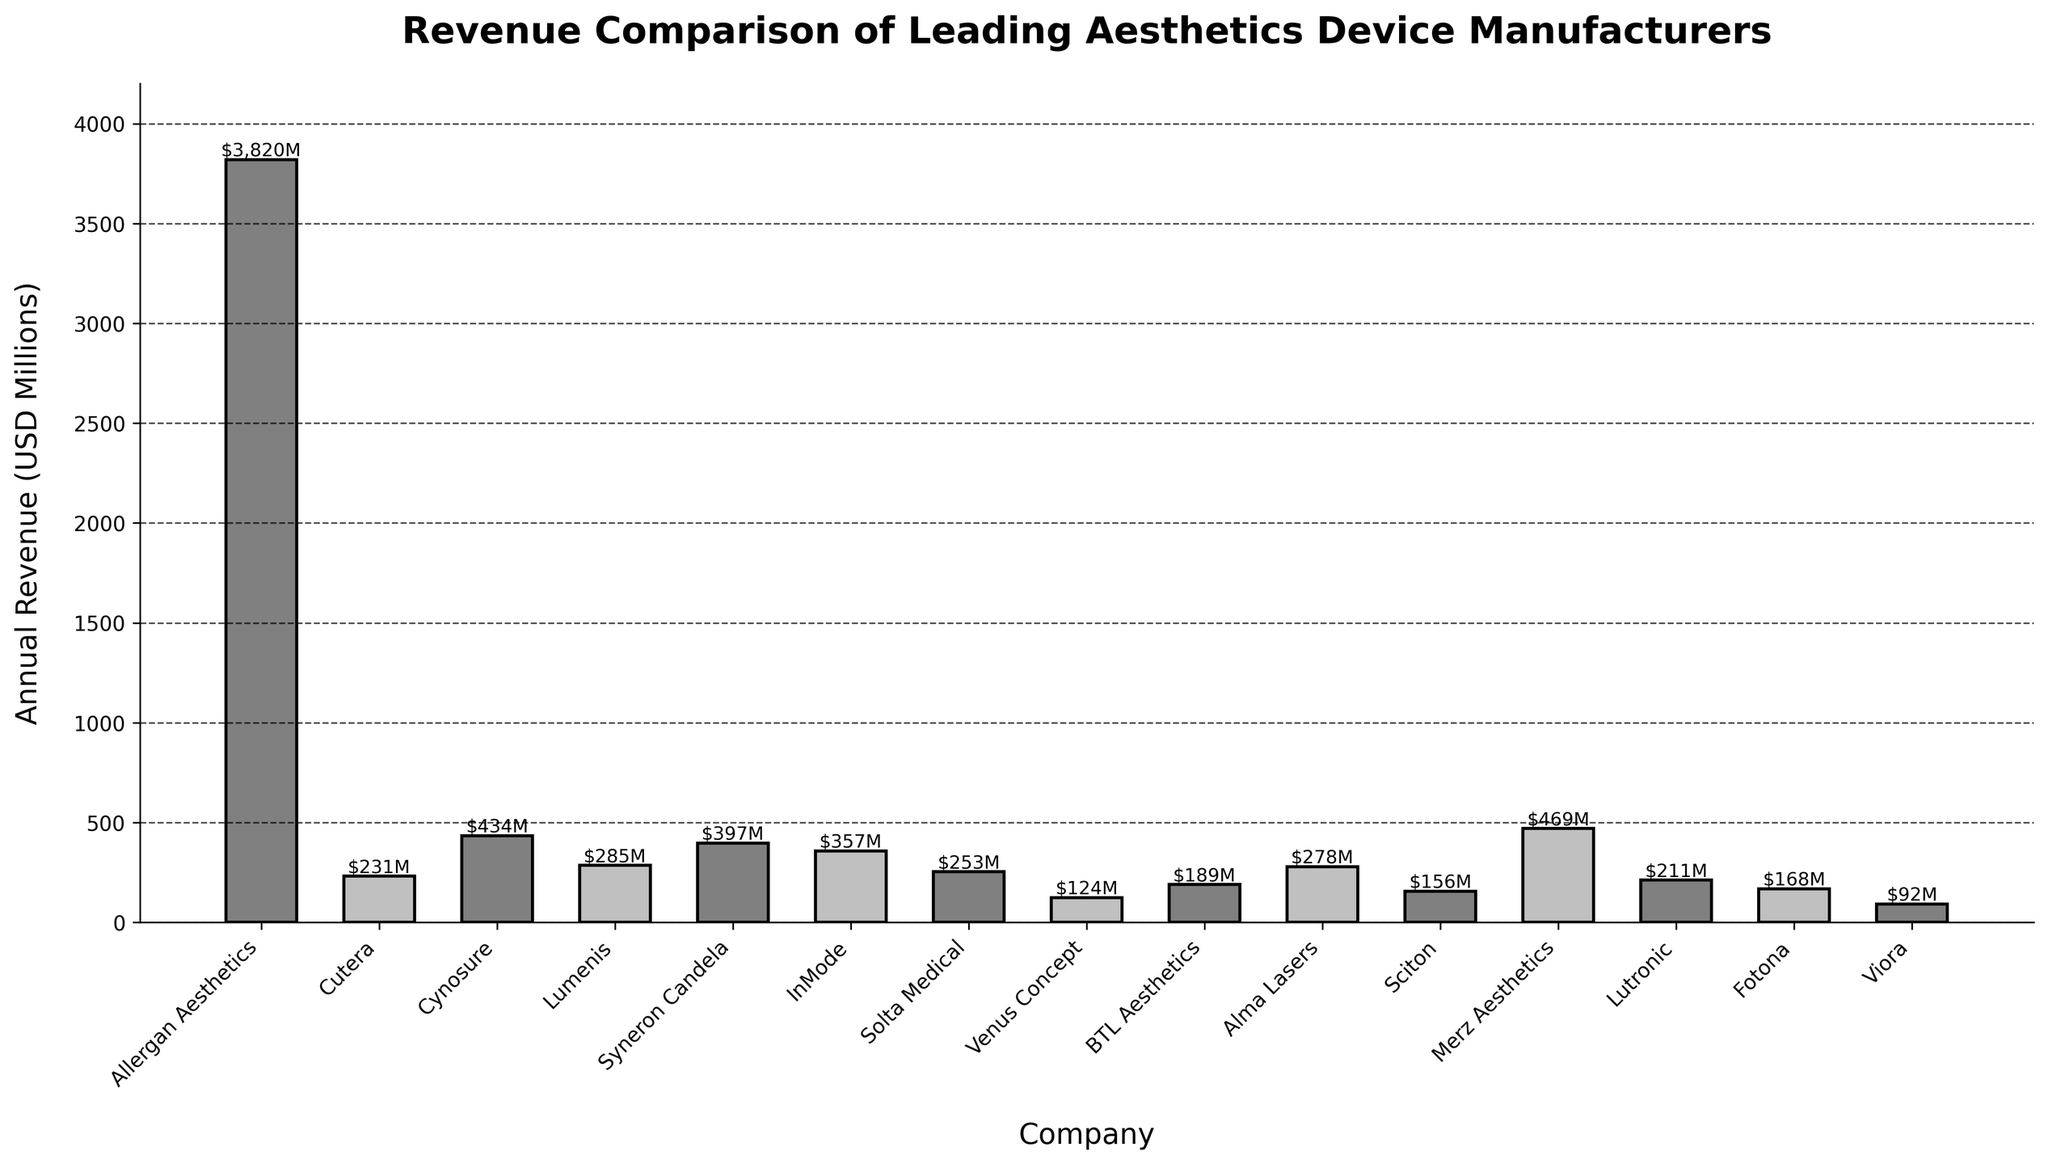Which company has the highest annual revenue? The height of the bars represents the annual revenue for each company, and the tallest bar indicates the company with the highest annual revenue. Allergan Aesthetics has the highest revenue.
Answer: Allergan Aesthetics Which companies have an annual revenue greater than $400 million? Easily identifiable by the heights of the bars, only those whose heights surpass the $400 million mark qualify. Allergan Aesthetics and Merz Aesthetics are the ones.
Answer: Allergan Aesthetics, Merz Aesthetics What is the total revenue of the top three companies? Sum the heights of the bars for the three highest values: Allergan Aesthetics ($3,820M), Merz Aesthetics ($469M), and Cynosure ($434M). The total is $3,820M + $469M + $434M.
Answer: $4,723M Which company has the lowest annual revenue? The shortest bar on the chart indicates the company with the lowest annual revenue. This bar represents Viora.
Answer: Viora What is the revenue range of the companies? Subtract the lowest revenue (Viora's $92M) from the highest revenue (Allergan Aesthetics' $3,820M).
Answer: $3,728M How many companies have a revenue between $200 million and $300 million? Count the number of bars whose heights correspond to values between $200M and $300M. The companies are Lumenis, Solta Medical, Lutronic, and Alma Lasers, amounting to four companies.
Answer: 4 What is the average revenue of all companies listed? Add up all the revenues and divide by the number of companies: (3820 + 231 + 434 + 285 + 397 + 357 + 253 + 124 + 189 + 278 + 156 + 469 + 211 + 168 + 92) / 15. The total revenue is $8,464M and the average is $8,464M / 15.
Answer: $564.27M Which companies have alternating bar colors the same as Lumenis? Lumenis has one of the bars colored grey. Identify all other bars painted in the same grey alternating pattern. The companies are Cynosure, InMode, BTL Aesthetics, Sciton, and Fotona.
Answer: Cynosure, InMode, BTL Aesthetics, Sciton, Fotona 